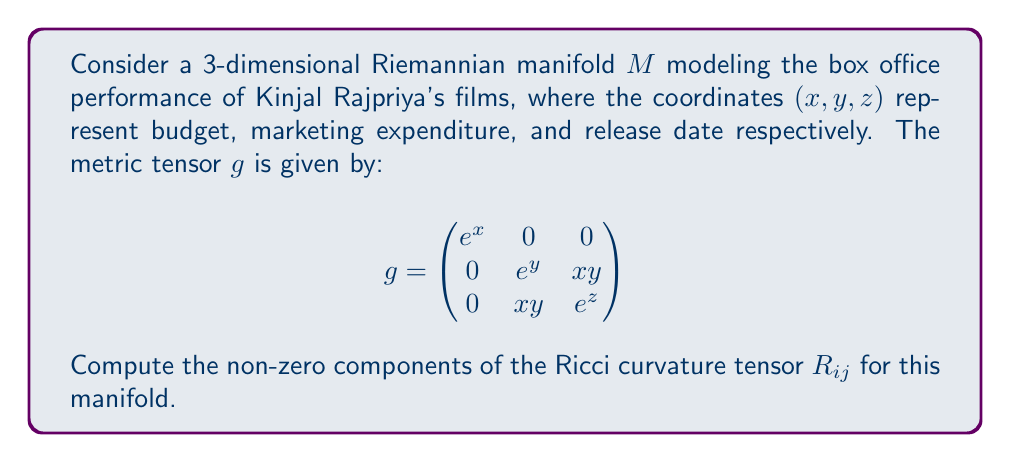Teach me how to tackle this problem. To compute the Ricci curvature tensor, we need to follow these steps:

1) First, calculate the Christoffel symbols $\Gamma^k_{ij}$ using the metric tensor:

   $$\Gamma^k_{ij} = \frac{1}{2}g^{kl}(\partial_i g_{jl} + \partial_j g_{il} - \partial_l g_{ij})$$

2) Then, compute the Riemann curvature tensor $R^l_{ijk}$:

   $$R^l_{ijk} = \partial_i \Gamma^l_{jk} - \partial_j \Gamma^l_{ik} + \Gamma^l_{im}\Gamma^m_{jk} - \Gamma^l_{jm}\Gamma^m_{ik}$$

3) Finally, contract the Riemann tensor to get the Ricci tensor:

   $$R_{ij} = R^k_{ikj}$$

Let's start with the Christoffel symbols:

$\Gamma^1_{11} = \frac{1}{2}e^{-x}(e^x) = \frac{1}{2}$
$\Gamma^2_{22} = \frac{1}{2}e^{-y}(e^y) = \frac{1}{2}$
$\Gamma^3_{33} = \frac{1}{2}e^{-z}(e^z) = \frac{1}{2}$
$\Gamma^2_{23} = \Gamma^2_{32} = \Gamma^3_{22} = \frac{1}{2}e^{-y}x$
$\Gamma^3_{23} = \Gamma^3_{32} = \frac{1}{2}e^{-z}x$

Now, let's compute the non-zero components of the Riemann tensor:

$R^1_{212} = -\frac{1}{4}e^x$
$R^1_{313} = -\frac{1}{4}e^x$
$R^2_{121} = -\frac{1}{4}e^y$
$R^2_{323} = -\frac{1}{4}e^y - \frac{1}{4}x^2$
$R^3_{131} = -\frac{1}{4}e^z$
$R^3_{232} = -\frac{1}{4}e^z - \frac{1}{4}x^2$

Finally, we can compute the Ricci tensor by contracting the Riemann tensor:

$R_{11} = R^1_{111} + R^2_{121} + R^3_{131} = 0 - \frac{1}{4}e^y - \frac{1}{4}e^z$
$R_{22} = R^1_{212} + R^2_{222} + R^3_{232} = -\frac{1}{4}e^x + 0 - \frac{1}{4}e^z - \frac{1}{4}x^2$
$R_{33} = R^1_{313} + R^2_{323} + R^3_{333} = -\frac{1}{4}e^x - \frac{1}{4}e^y - \frac{1}{4}x^2 + 0$
$R_{23} = R_{32} = 0$
Answer: The non-zero components of the Ricci curvature tensor are:

$$R_{11} = -\frac{1}{4}e^y - \frac{1}{4}e^z$$
$$R_{22} = -\frac{1}{4}e^x - \frac{1}{4}e^z - \frac{1}{4}x^2$$
$$R_{33} = -\frac{1}{4}e^x - \frac{1}{4}e^y - \frac{1}{4}x^2$$ 